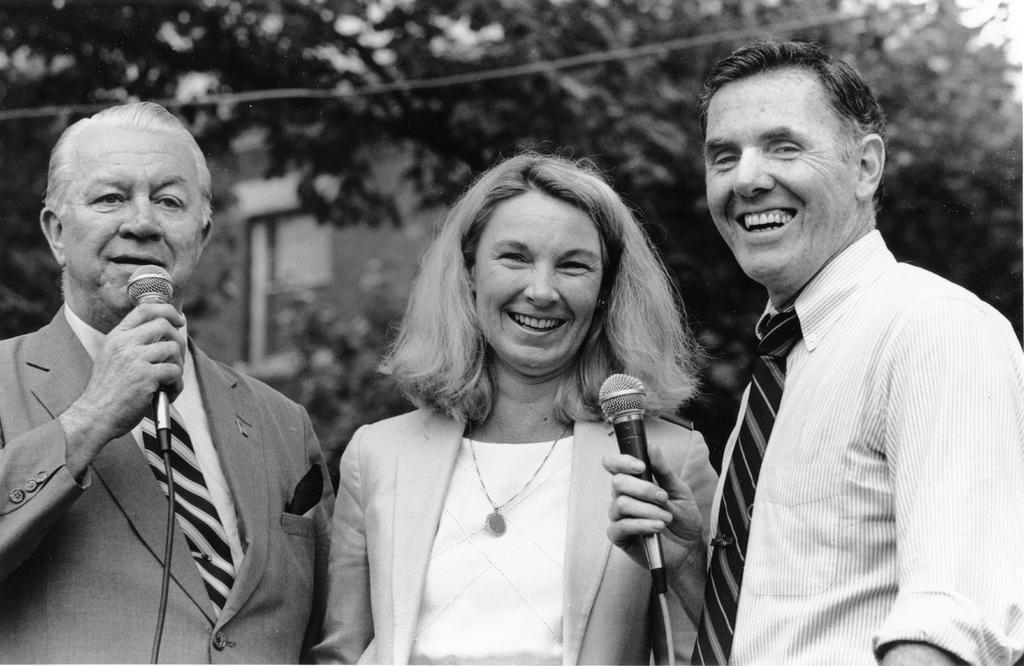What type of natural elements can be seen in the image? There are trees in the image. What type of man-made structure is present in the image? There is a building in the image. How many people are in the image? There are three people in the image. What are two of the people holding in the image? Two of the people are holding microphones. Are there any pets visible in the image? There are no pets present in the image. What type of protest is taking place in the image? There is no protest depicted in the image. 